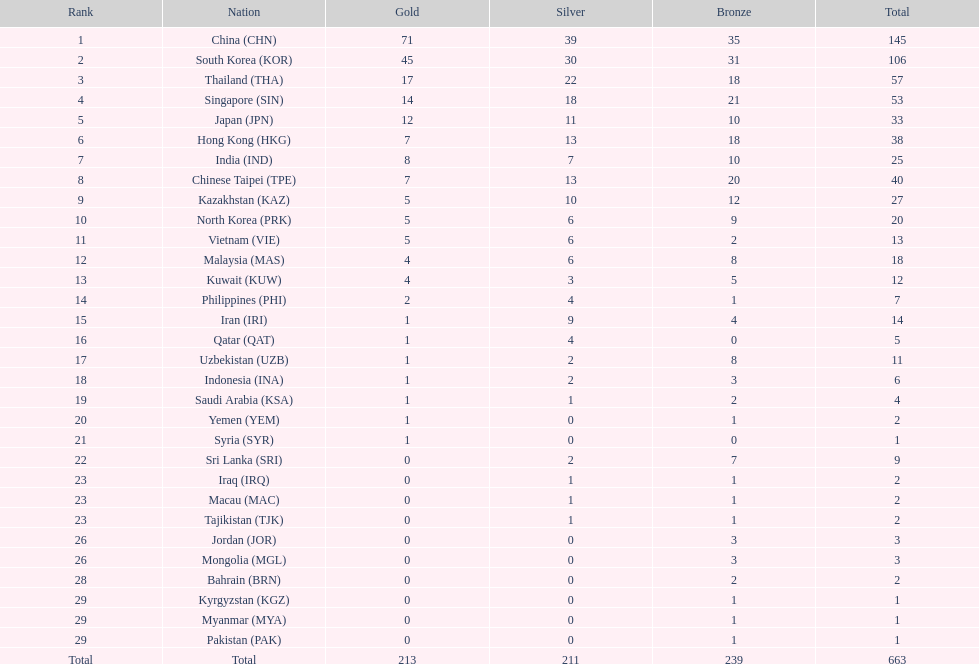Which countries have the same number of silver medals in the asian youth games as north korea? Vietnam (VIE), Malaysia (MAS). 